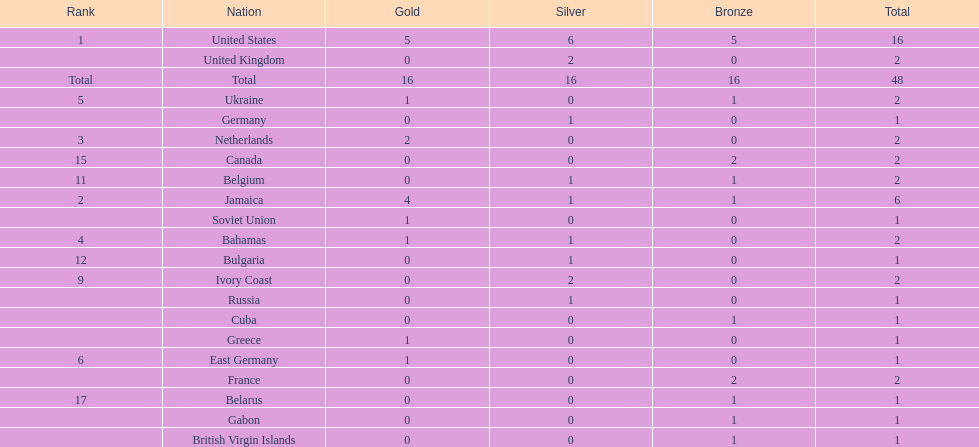Can you give me this table as a dict? {'header': ['Rank', 'Nation', 'Gold', 'Silver', 'Bronze', 'Total'], 'rows': [['1', 'United States', '5', '6', '5', '16'], ['', 'United Kingdom', '0', '2', '0', '2'], ['Total', 'Total', '16', '16', '16', '48'], ['5', 'Ukraine', '1', '0', '1', '2'], ['', 'Germany', '0', '1', '0', '1'], ['3', 'Netherlands', '2', '0', '0', '2'], ['15', 'Canada', '0', '0', '2', '2'], ['11', 'Belgium', '0', '1', '1', '2'], ['2', 'Jamaica', '4', '1', '1', '6'], ['', 'Soviet Union', '1', '0', '0', '1'], ['4', 'Bahamas', '1', '1', '0', '2'], ['12', 'Bulgaria', '0', '1', '0', '1'], ['9', 'Ivory Coast', '0', '2', '0', '2'], ['', 'Russia', '0', '1', '0', '1'], ['', 'Cuba', '0', '0', '1', '1'], ['', 'Greece', '1', '0', '0', '1'], ['6', 'East Germany', '1', '0', '0', '1'], ['', 'France', '0', '0', '2', '2'], ['17', 'Belarus', '0', '0', '1', '1'], ['', 'Gabon', '0', '0', '1', '1'], ['', 'British Virgin Islands', '0', '0', '1', '1']]} Which countries won at least 3 silver medals? United States. 